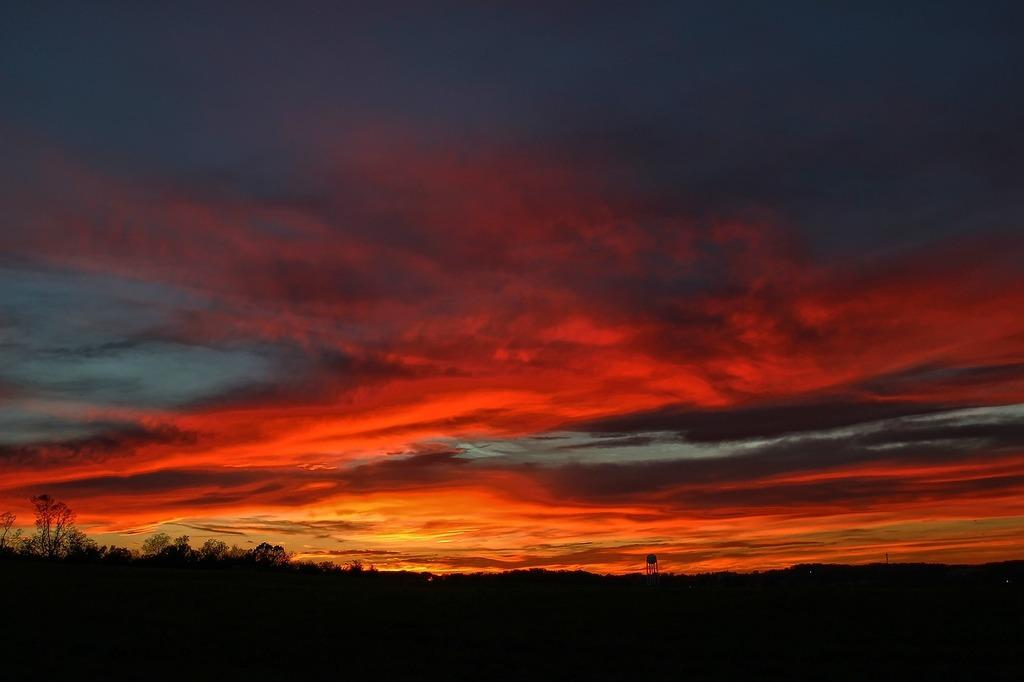What type of vegetation can be seen in the image? There are trees in the image. What is visible in the background of the image? The sky is visible in the background of the image. What can be observed in the sky? Clouds are present in the sky. What type of pear is hanging from the tree in the image? There is no pear present in the image; it only features trees and clouds in the sky. 